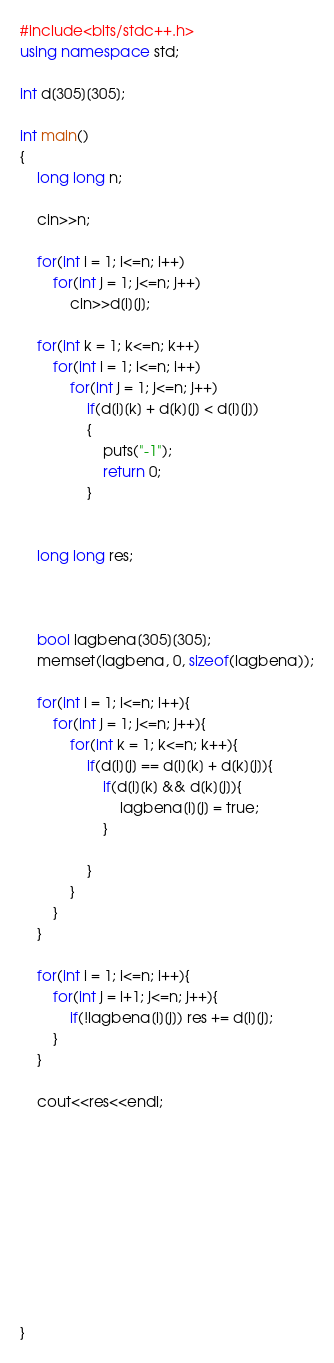Convert code to text. <code><loc_0><loc_0><loc_500><loc_500><_C++_>#include<bits/stdc++.h>
using namespace std;

int d[305][305];

int main()
{
    long long n;

    cin>>n;

    for(int i = 1; i<=n; i++)
        for(int j = 1; j<=n; j++)
            cin>>d[i][j];

    for(int k = 1; k<=n; k++)
        for(int i = 1; i<=n; i++)
            for(int j = 1; j<=n; j++)
                if(d[i][k] + d[k][j] < d[i][j])
                {
                    puts("-1");
                    return 0;
                }


    long long res;



    bool lagbena[305][305];
    memset(lagbena, 0, sizeof(lagbena));

    for(int i = 1; i<=n; i++){
        for(int j = 1; j<=n; j++){
            for(int k = 1; k<=n; k++){
                if(d[i][j] == d[i][k] + d[k][j]){
                    if(d[i][k] && d[k][j]){
                        lagbena[i][j] = true;
                    }

                }
            }
        }
    }

    for(int i = 1; i<=n; i++){
        for(int j = i+1; j<=n; j++){
            if(!lagbena[i][j]) res += d[i][j];
        }
    }

    cout<<res<<endl;










}
</code> 